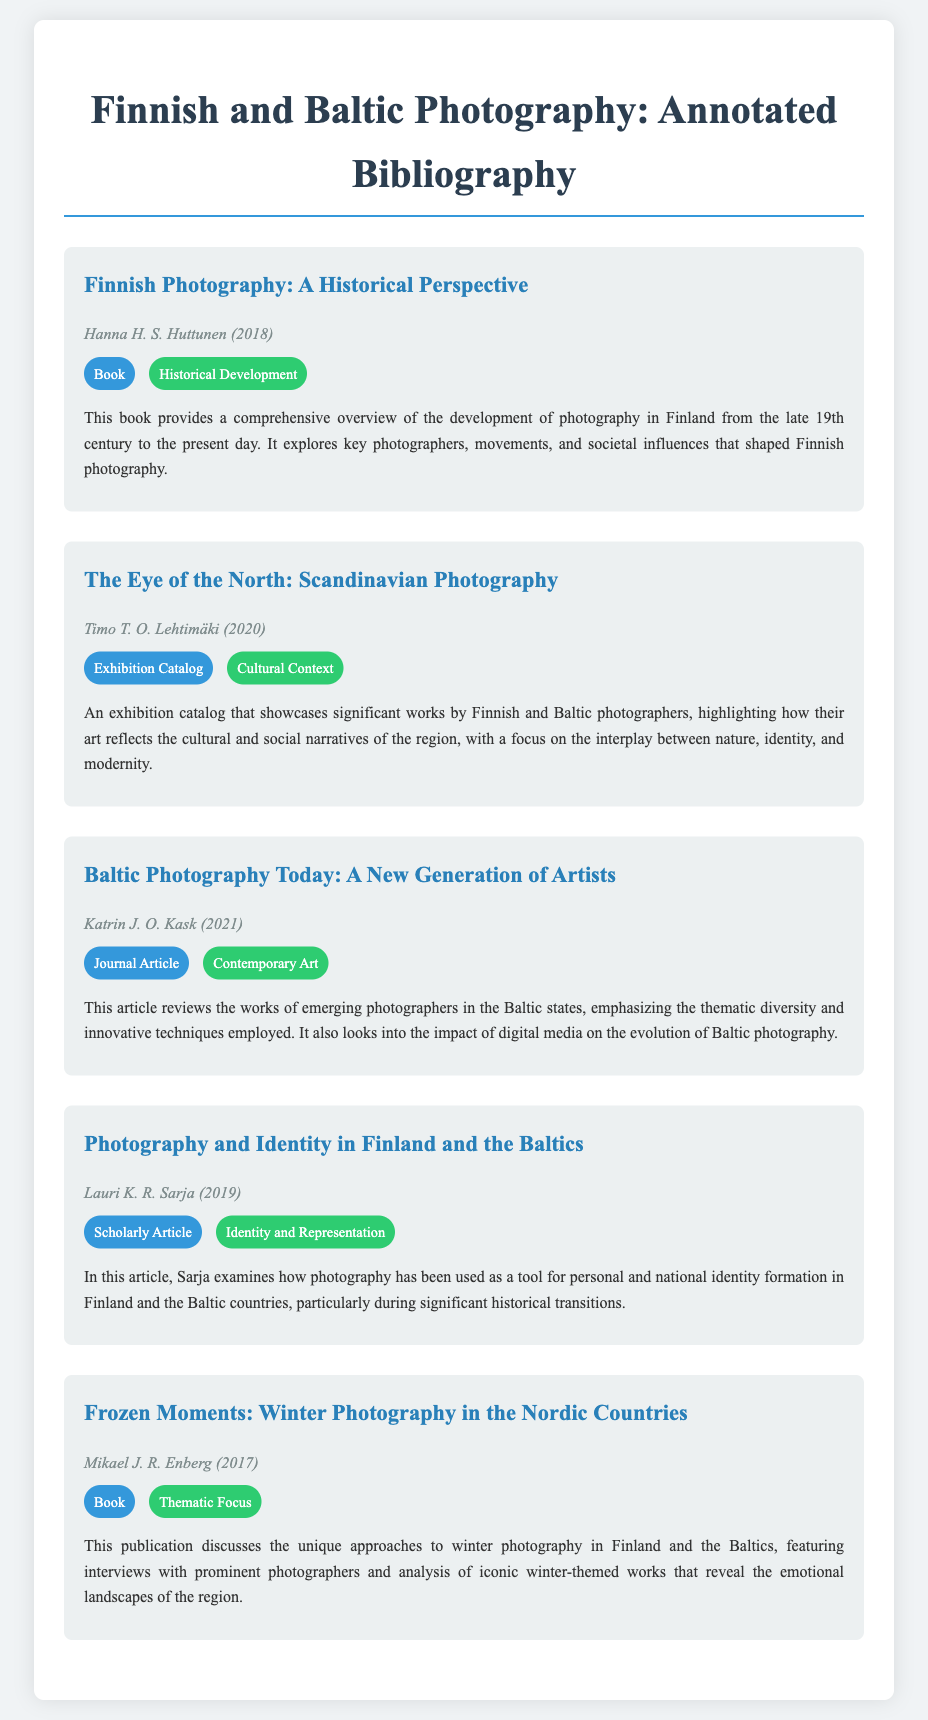what is the title of the first entry? The title is clearly mentioned at the beginning of each entry, which lists the works in the bibliography.
Answer: Finnish Photography: A Historical Perspective who is the author of "The Eye of the North: Scandinavian Photography"? Each entry includes the name of the author right after the title, which provides the relevant details for each work.
Answer: Timo T. O. Lehtimäki what type of document is "Baltic Photography Today: A New Generation of Artists"? The type of each document is stated alongside the title, providing context for the reader about the nature of the work.
Answer: Journal Article how many themes are listed in total? By counting the unique themes presented in each entry, we can determine the total number of themes covered in the bibliography.
Answer: 5 which year was "Frozen Moments: Winter Photography in the Nordic Countries" published? The publication year is indicated next to the author's name for each entry, offering a quick reference to the release dates.
Answer: 2017 what theme does "Photography and Identity in Finland and the Baltics" focus on? The focus of each entry is highlighted with a theme label, specifying the subject matter of the work.
Answer: Identity and Representation who wrote the book on Finnish photography's historical perspective? The author's name accompanies each title to attribute the work properly, making it easy to reference authorship.
Answer: Hanna H. S. Huttunen what is the main focus of the second entry? Each entry includes a summary that outlines the primary topics discussed, providing insight into the content's purpose.
Answer: Cultural and social narratives 